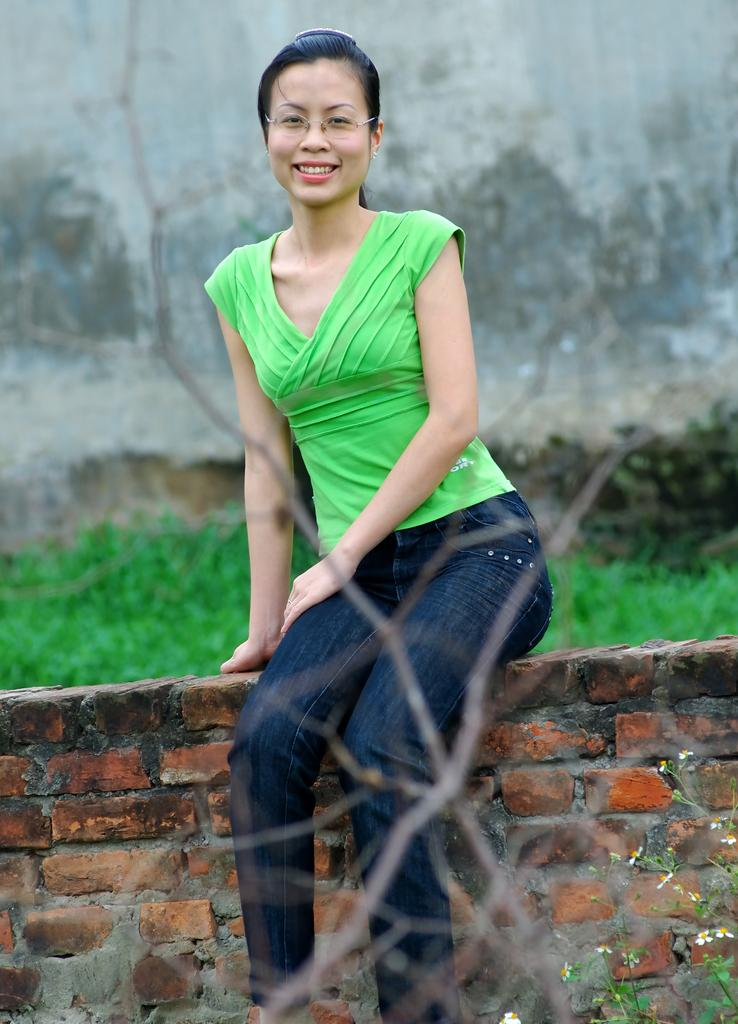Who is present in the image? There is a woman in the image. What is the woman wearing? The woman is wearing a green top. What is the woman's facial expression? The woman is smiling. Where is the woman sitting? The woman is sitting on a brick wall. What can be seen in the background of the image? There are plants and a wall in the background of the image. What type of rose can be seen in the woman's hand in the image? There is no rose present in the image; the woman is not holding anything in her hand. 